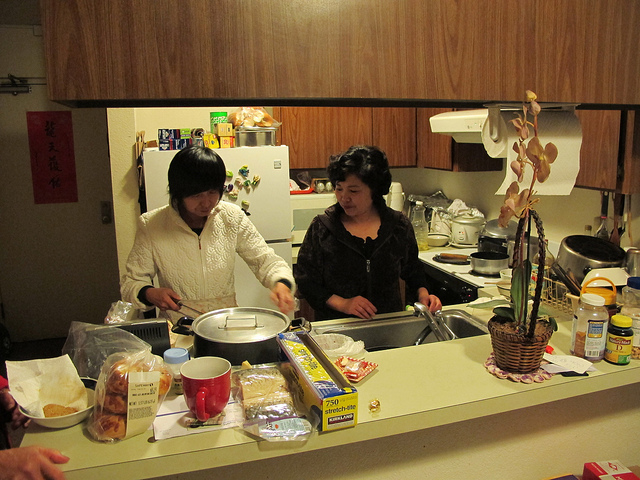Please transcribe the text information in this image. 750 strech 